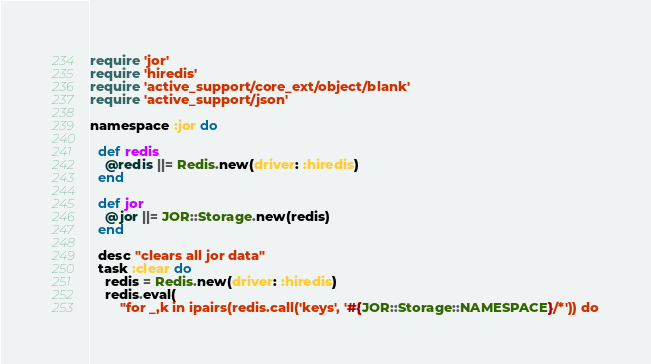<code> <loc_0><loc_0><loc_500><loc_500><_Ruby_>require 'jor'
require 'hiredis'
require 'active_support/core_ext/object/blank'
require 'active_support/json'

namespace :jor do

  def redis
    @redis ||= Redis.new(driver: :hiredis)
  end

  def jor
    @jor ||= JOR::Storage.new(redis)
  end

  desc "clears all jor data"
  task :clear do
    redis = Redis.new(driver: :hiredis)
    redis.eval(
        "for _,k in ipairs(redis.call('keys', '#{JOR::Storage::NAMESPACE}/*')) do</code> 